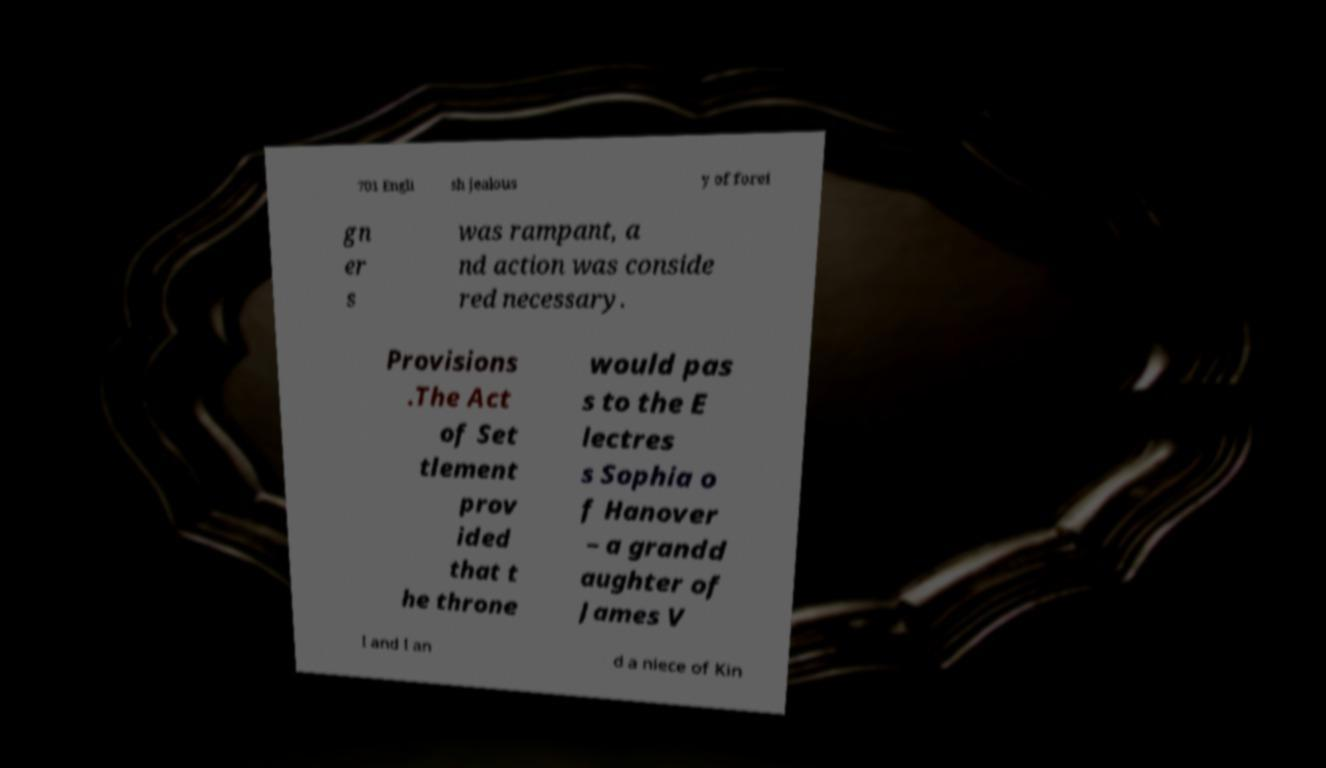For documentation purposes, I need the text within this image transcribed. Could you provide that? 701 Engli sh jealous y of forei gn er s was rampant, a nd action was conside red necessary. Provisions .The Act of Set tlement prov ided that t he throne would pas s to the E lectres s Sophia o f Hanover – a grandd aughter of James V I and I an d a niece of Kin 